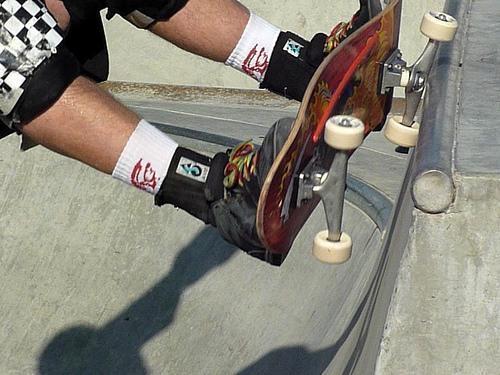How many feet are there?
Give a very brief answer. 2. How many axles are touching the rail?
Give a very brief answer. 1. 